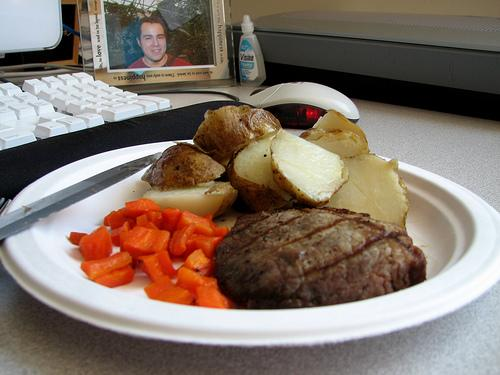Where is this kind of plate normally used?

Choices:
A) diner
B) picnic
C) bar
D) wedding picnic 